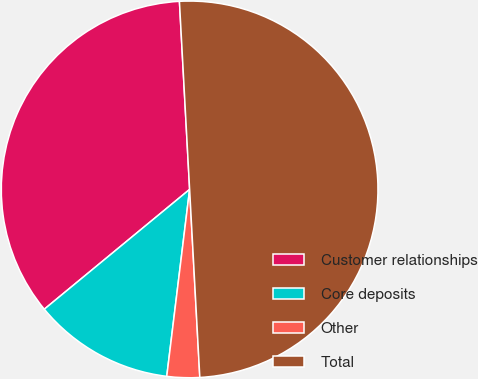<chart> <loc_0><loc_0><loc_500><loc_500><pie_chart><fcel>Customer relationships<fcel>Core deposits<fcel>Other<fcel>Total<nl><fcel>35.11%<fcel>12.09%<fcel>2.8%<fcel>50.0%<nl></chart> 